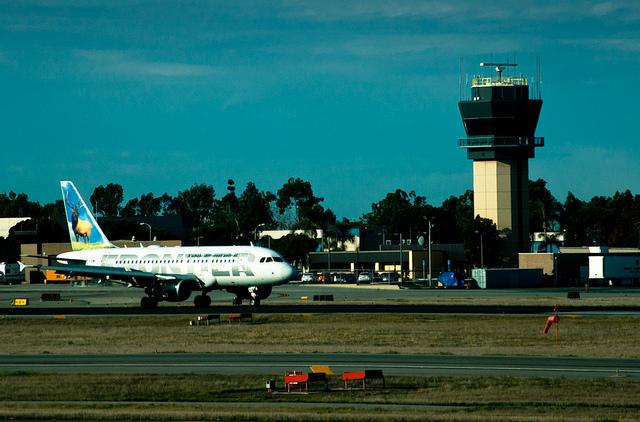Where was this photo taken?
Keep it brief. Airport. What animal is on the plane's tail?
Be succinct. Moose. What word is on the side of the plane?
Write a very short answer. Frontier. 